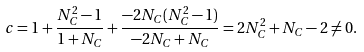Convert formula to latex. <formula><loc_0><loc_0><loc_500><loc_500>c = 1 + \frac { N _ { C } ^ { 2 } - 1 } { 1 + N _ { C } } + \frac { - 2 N _ { C } ( N _ { C } ^ { 2 } - 1 ) } { - 2 N _ { C } + N _ { C } } = 2 N _ { C } ^ { 2 } + N _ { C } - 2 \neq 0 .</formula> 